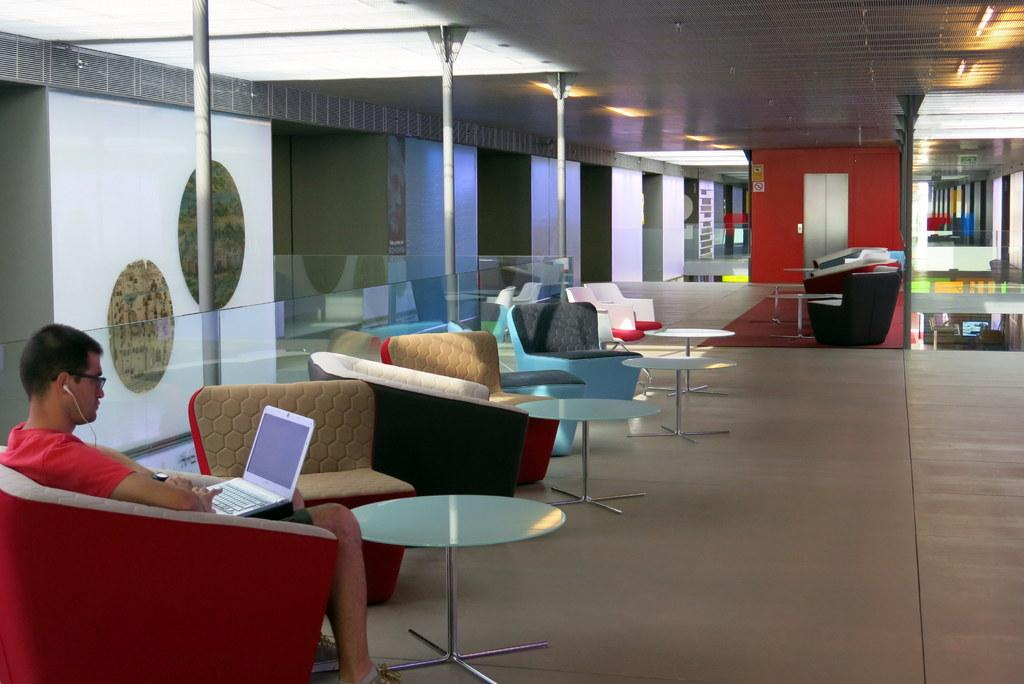What type of furniture can be seen in the image? There are chairs and tables in the image. What is the man in the image doing? The man is sitting on a chair in the image. What object does the man have with him while sitting on the chair? The man has a laptop in his lap. How many spiders are crawling on the man's laptop in the image? There are no spiders present in the image; the man has a laptop in his lap. What type of material is the table made of in the image? The provided facts do not mention the material of the table, so it cannot be determined from the image. 